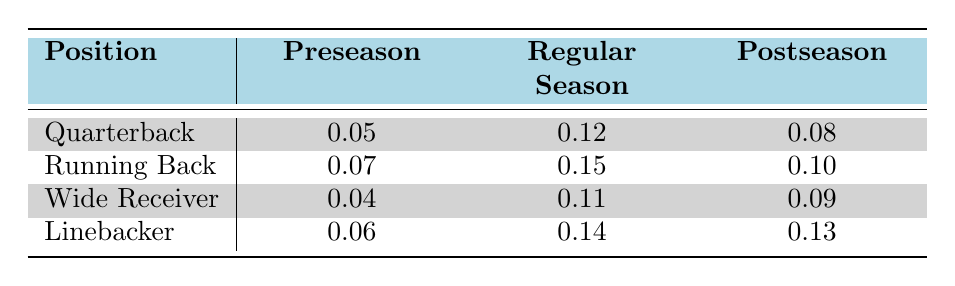What is the injury occurrence rate for Running Backs during the Regular Season? According to the table, the injury occurrence rate for Running Backs during the Regular Season is clearly indicated as 0.15.
Answer: 0.15 Which position has the highest injury occurrence rate in the Postseason? From the table, we can see that the injury occurrence rates in the Postseason are: Quarterback (0.08), Running Back (0.10), Wide Receiver (0.09), and Linebacker (0.13). The highest rate is 0.13 for Linebackers.
Answer: Linebacker What is the difference in injury occurrence rates between Quarterbacks in the Regular Season and Postseason? The injury occurrence rate for Quarterbacks in the Regular Season is 0.12, and in the Postseason, it is 0.08. The difference can be calculated as 0.12 - 0.08 = 0.04.
Answer: 0.04 Is the injury occurrence rate for Wide Receivers higher in the Regular Season than in the Preseason? Looking at the data, the injury occurrence rate for Wide Receivers in the Regular Season is 0.11, while in the Preseason, it is 0.04. Since 0.11 is greater than 0.04, the statement is true.
Answer: Yes What is the average injury occurrence rate for all player positions during the Preseason? The injury occurrence rates during the Preseason are 0.05 (Quarterback), 0.07 (Running Back), 0.04 (Wide Receiver), and 0.06 (Linebacker). To find the average, we sum these values: 0.05 + 0.07 + 0.04 + 0.06 = 0.22. Then we divide by 4, the number of positions: 0.22 / 4 = 0.055.
Answer: 0.055 Do Quarterbacks have a higher injury occurrence rate in the Regular Season compared to Linebackers during the same phase? The injury occurrence rate for Quarterbacks during the Regular Season is 0.12, and for Linebackers, it is 0.14. Since 0.12 is less than 0.14, the statement is false.
Answer: No Which season phase sees the highest average injury occurrence rate across all player positions? To find the average injury occurrence rate for each season phase, we calculate as follows: Preseason: (0.05 + 0.07 + 0.04 + 0.06)/4 = 0.055; Regular Season: (0.12 + 0.15 + 0.11 + 0.14)/4 = 0.115; Postseason: (0.08 + 0.10 + 0.09 + 0.13)/4 = 0.10. The highest average is in the Regular Season at 0.115.
Answer: Regular Season Which player position had the lowest injury occurrence rate during Preseason? Examining the Preseason rates: Quarterback (0.05), Running Back (0.07), Wide Receiver (0.04), and Linebacker (0.06), the lowest rate is 0.04 for Wide Receivers.
Answer: Wide Receiver 